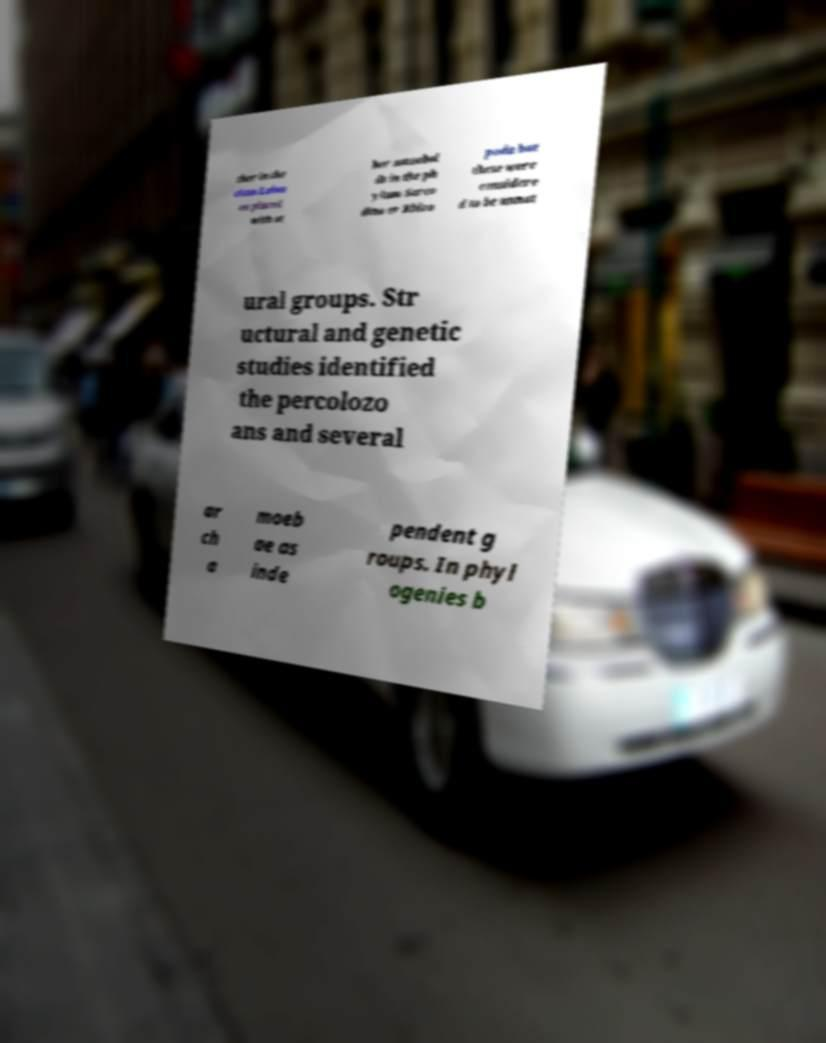There's text embedded in this image that I need extracted. Can you transcribe it verbatim? ther in the class Lobos ea placed with ot her amoeboi ds in the ph ylum Sarco dina or Rhizo poda but these were considere d to be unnat ural groups. Str uctural and genetic studies identified the percolozo ans and several ar ch a moeb ae as inde pendent g roups. In phyl ogenies b 